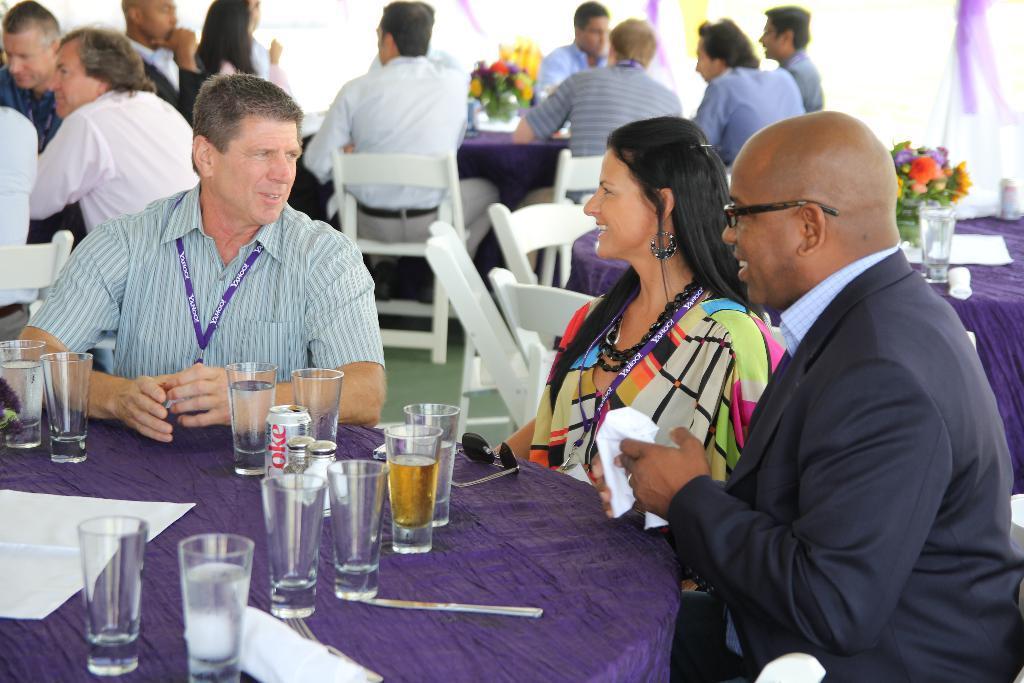Describe this image in one or two sentences. In this picture we can see few persons sitting on chairs in front of a table. There are flower vase on the table and we can also see coke tin and drinking glasses on the table. This is a floor carpet in green colour. On the background we can see it is decorated with a white and a purple cloth. 